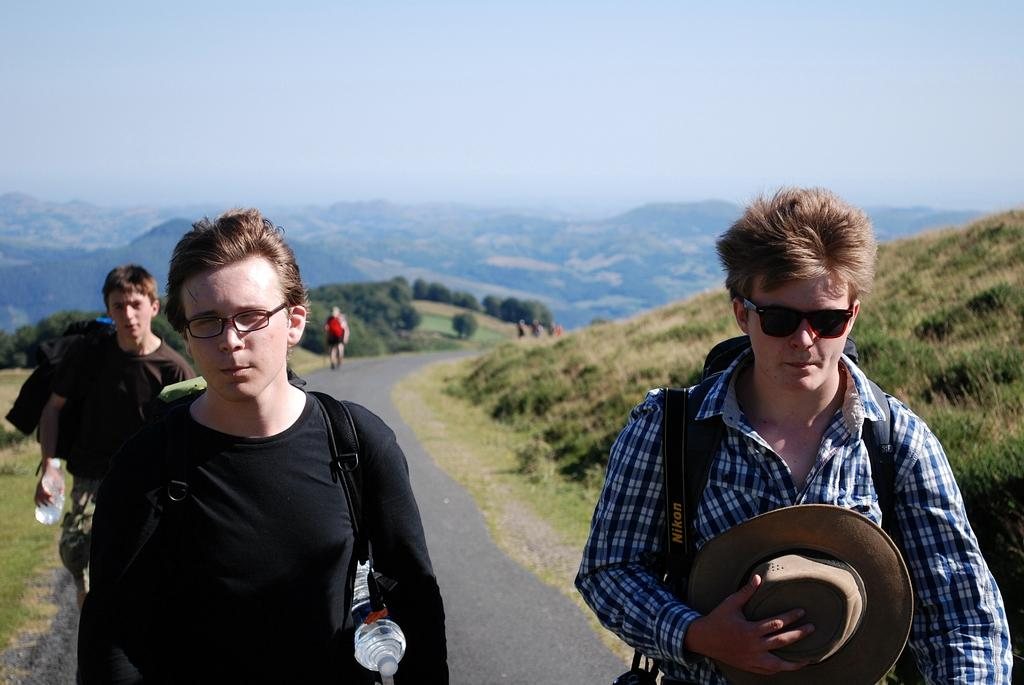What is the main subject of the image? The main subject of the image is a group of people. Can you describe any specific features of the people in the group? Some people in the group are wearing spectacles, and some are wearing bags. What can be seen in the background of the image? There are trees and hills in the background of the image. What type of steel is being used to construct the expansion in the image? There is no steel or expansion present in the image; it features a group of people with trees and hills in the background. 